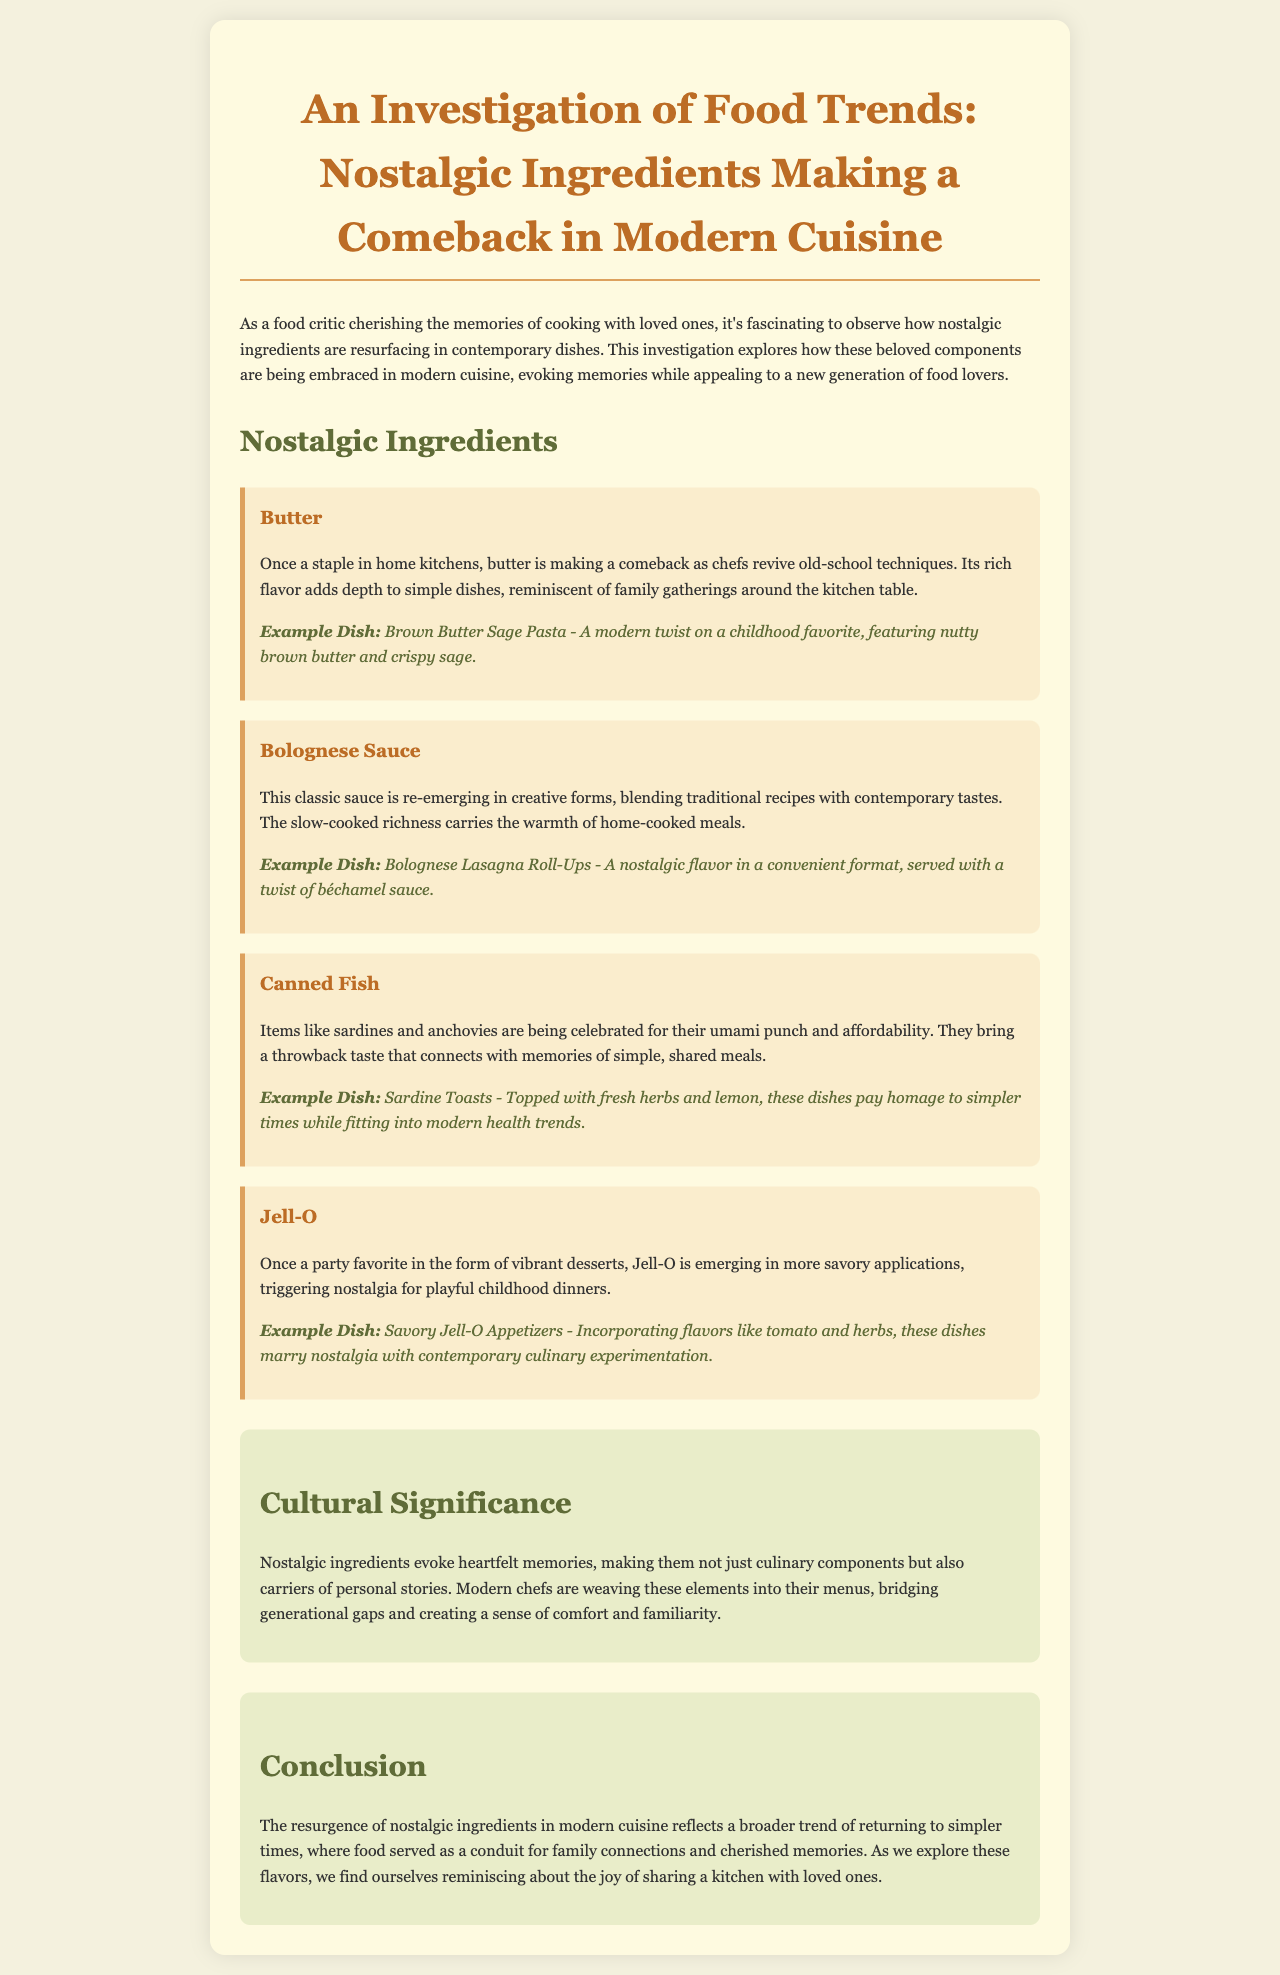What are the four nostalgic ingredients mentioned? The document lists butter, Bolognese sauce, canned fish, and Jell-O as nostalgic ingredients in modern cuisine.
Answer: butter, Bolognese sauce, canned fish, Jell-O What is the example dish for butter? The example dish given for butter is Brown Butter Sage Pasta.
Answer: Brown Butter Sage Pasta How does the document describe the cultural significance of nostalgic ingredients? The document explains that nostalgic ingredients evoke heartfelt memories and serve as carriers of personal stories, bridging generational gaps.
Answer: They evoke heartfelt memories Which nostalgic ingredient is associated with umami flavor? Canned fish, such as sardines and anchovies, is noted for its umami punch.
Answer: Canned fish What modern twist is presented for Jell-O in the investigation? The document describes savory applications of Jell-O, incorporating flavors like tomato and herbs.
Answer: Savory Jell-O Appetizers How does the investigation define the broader trend in modern cuisine? The investigation indicates this trend reflects a return to simpler times, focusing on food as a connection for families.
Answer: Returning to simpler times What is a notable characteristic of Bolognese sauce in modern cuisine? Bolognese sauce is being blended with contemporary tastes while retaining its traditional recipes.
Answer: Blending traditional recipes with contemporary tastes What type of dinner does the document associate with Jell-O? The document associates Jell-O with playful childhood dinners, hinting at its nostalgic nature.
Answer: Playful childhood dinners 